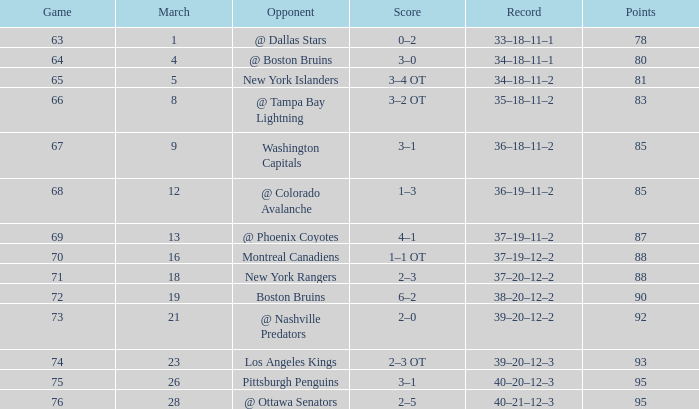Which Opponent has a Record of 38–20–12–2? Boston Bruins. 